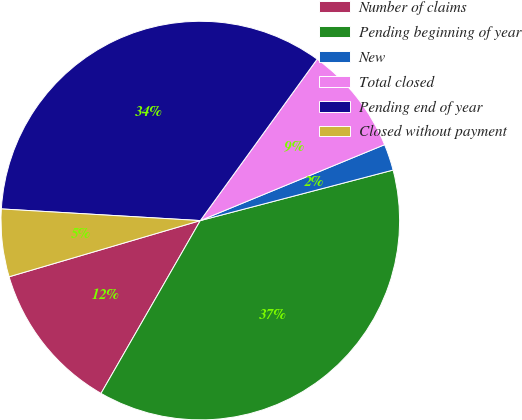Convert chart to OTSL. <chart><loc_0><loc_0><loc_500><loc_500><pie_chart><fcel>Number of claims<fcel>Pending beginning of year<fcel>New<fcel>Total closed<fcel>Pending end of year<fcel>Closed without payment<nl><fcel>12.15%<fcel>37.38%<fcel>2.14%<fcel>8.81%<fcel>34.04%<fcel>5.48%<nl></chart> 